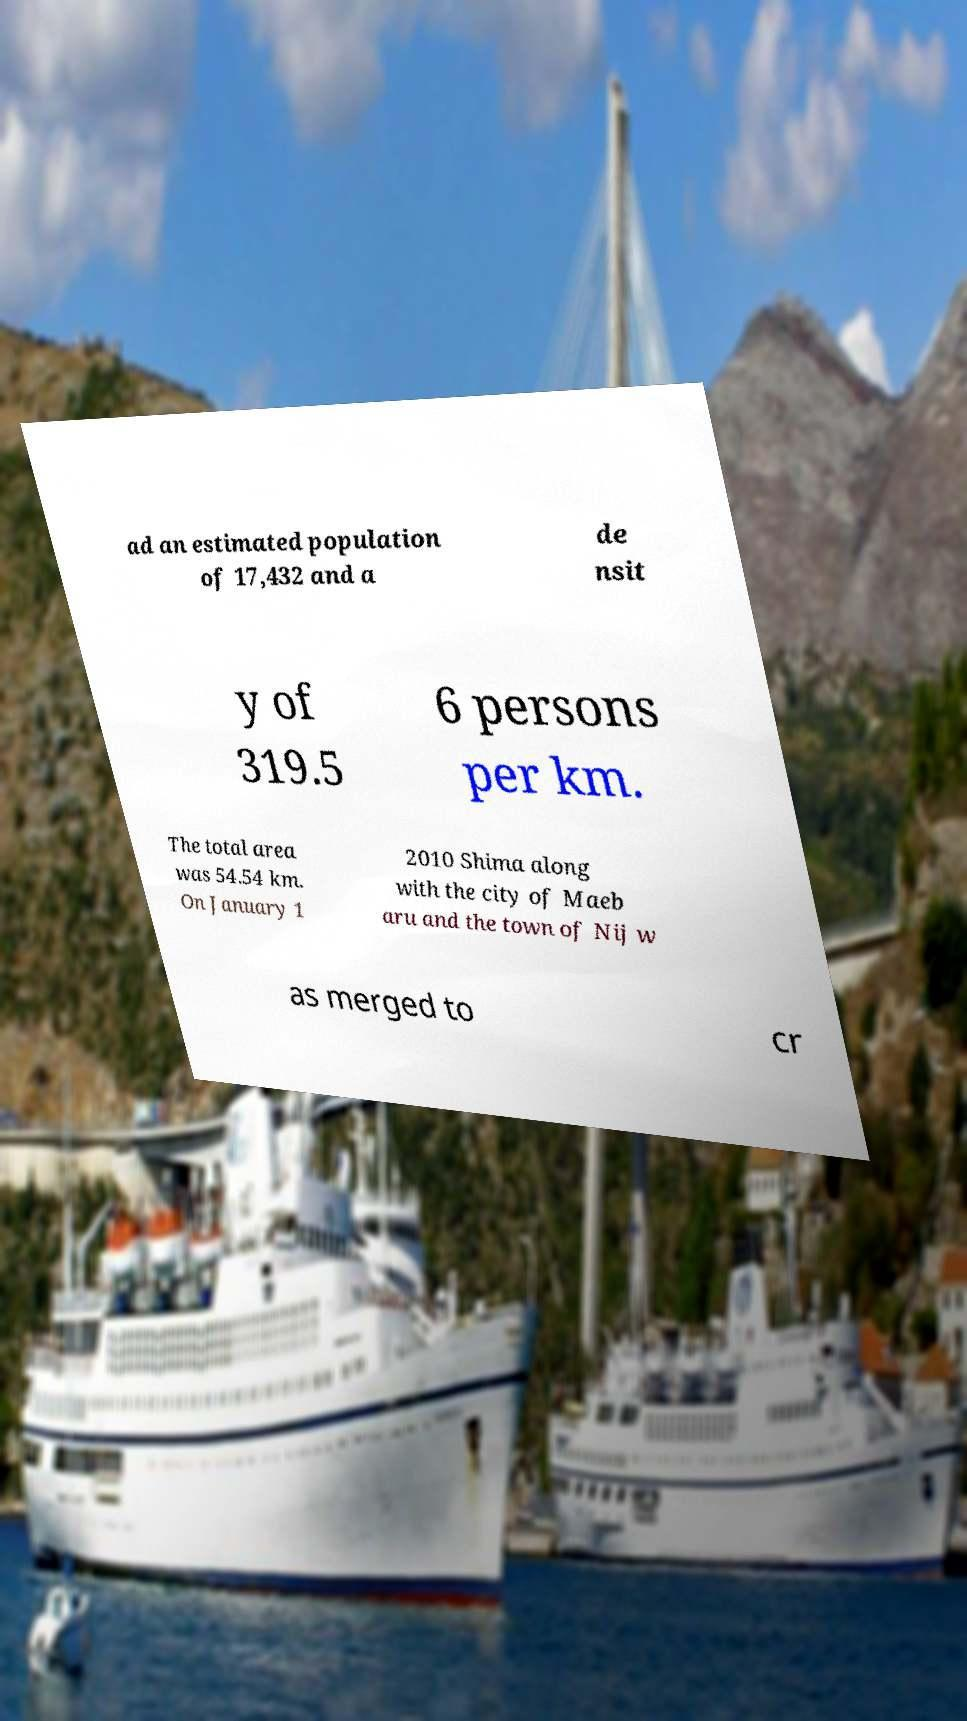For documentation purposes, I need the text within this image transcribed. Could you provide that? ad an estimated population of 17,432 and a de nsit y of 319.5 6 persons per km. The total area was 54.54 km. On January 1 2010 Shima along with the city of Maeb aru and the town of Nij w as merged to cr 